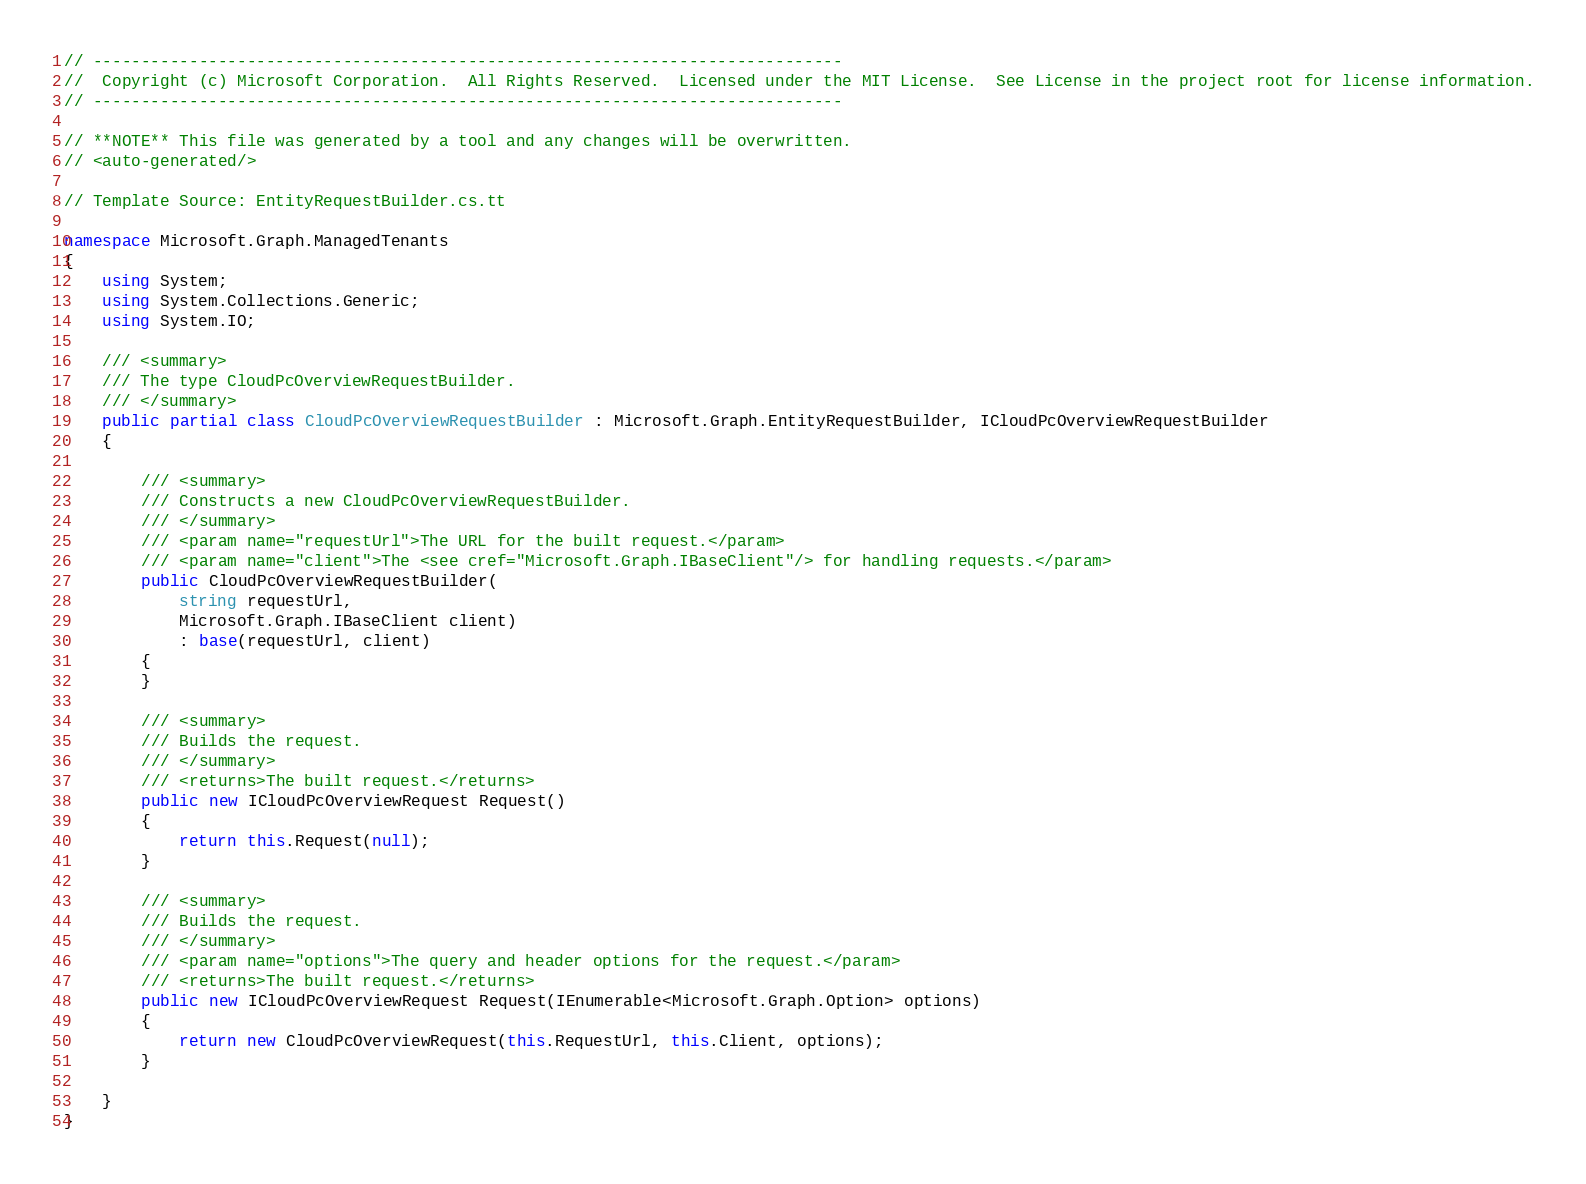<code> <loc_0><loc_0><loc_500><loc_500><_C#_>// ------------------------------------------------------------------------------
//  Copyright (c) Microsoft Corporation.  All Rights Reserved.  Licensed under the MIT License.  See License in the project root for license information.
// ------------------------------------------------------------------------------

// **NOTE** This file was generated by a tool and any changes will be overwritten.
// <auto-generated/>

// Template Source: EntityRequestBuilder.cs.tt

namespace Microsoft.Graph.ManagedTenants
{
    using System;
    using System.Collections.Generic;
    using System.IO;

    /// <summary>
    /// The type CloudPcOverviewRequestBuilder.
    /// </summary>
    public partial class CloudPcOverviewRequestBuilder : Microsoft.Graph.EntityRequestBuilder, ICloudPcOverviewRequestBuilder
    {

        /// <summary>
        /// Constructs a new CloudPcOverviewRequestBuilder.
        /// </summary>
        /// <param name="requestUrl">The URL for the built request.</param>
        /// <param name="client">The <see cref="Microsoft.Graph.IBaseClient"/> for handling requests.</param>
        public CloudPcOverviewRequestBuilder(
            string requestUrl,
            Microsoft.Graph.IBaseClient client)
            : base(requestUrl, client)
        {
        }

        /// <summary>
        /// Builds the request.
        /// </summary>
        /// <returns>The built request.</returns>
        public new ICloudPcOverviewRequest Request()
        {
            return this.Request(null);
        }

        /// <summary>
        /// Builds the request.
        /// </summary>
        /// <param name="options">The query and header options for the request.</param>
        /// <returns>The built request.</returns>
        public new ICloudPcOverviewRequest Request(IEnumerable<Microsoft.Graph.Option> options)
        {
            return new CloudPcOverviewRequest(this.RequestUrl, this.Client, options);
        }
    
    }
}
</code> 